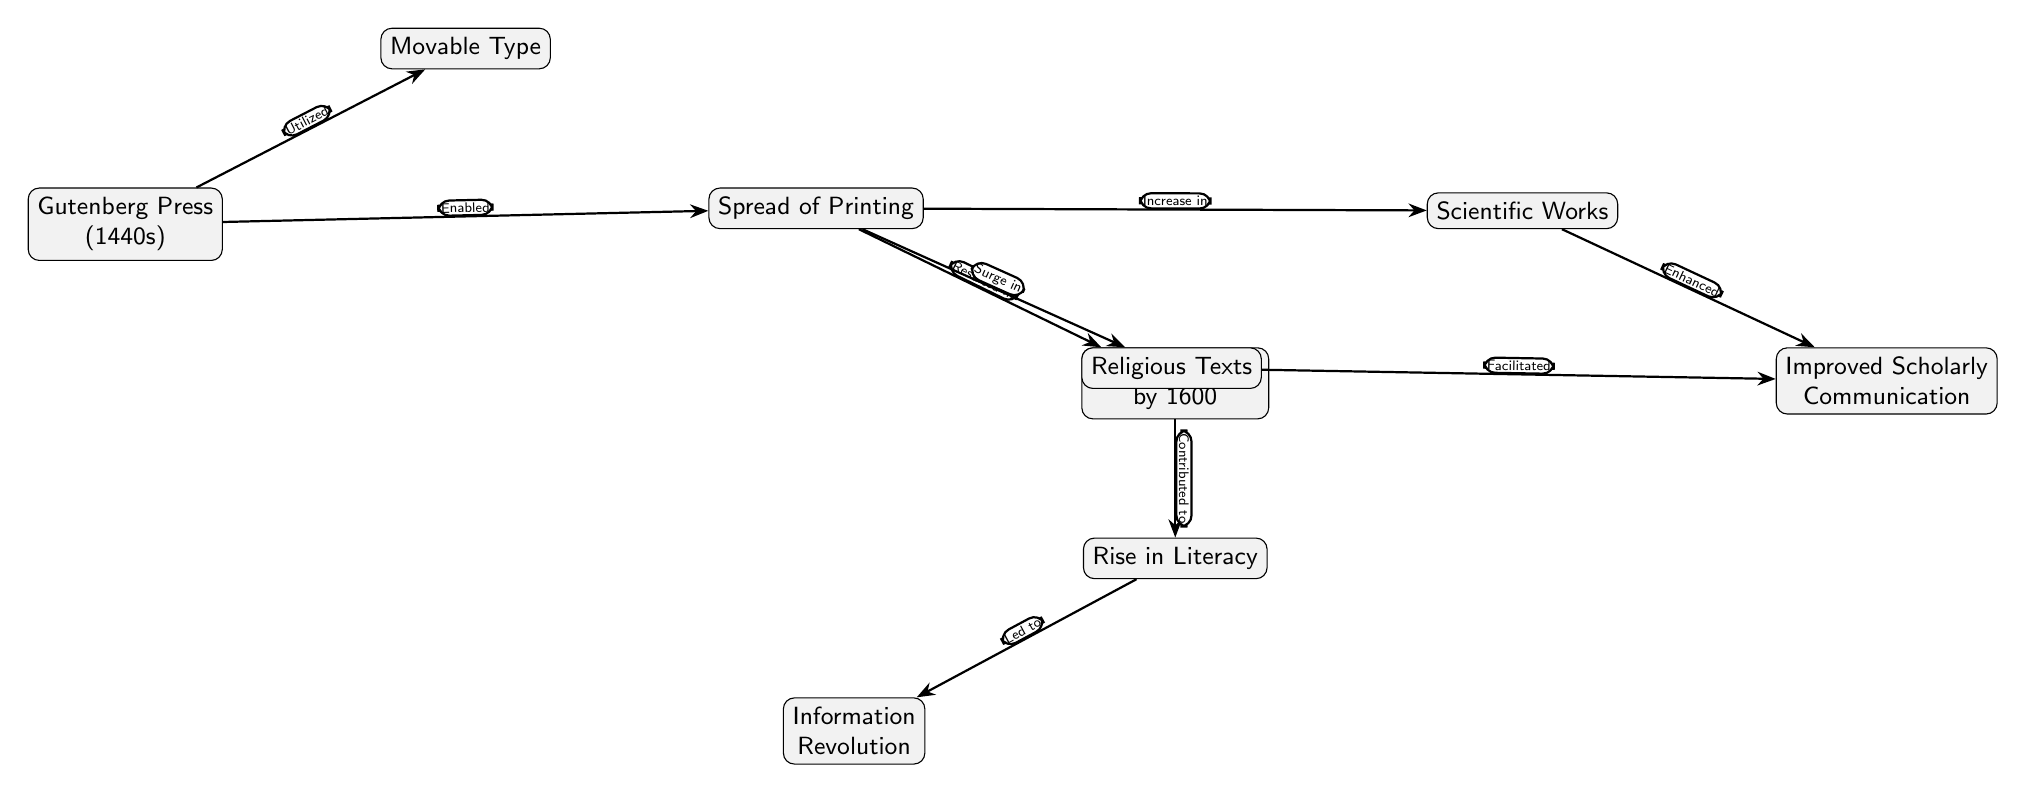What technology did Gutenberg utilize in the 1440s? The diagram indicates that Gutenberg utilized "Movable Type" as part of his printing technology in the 1440s. This is shown as a direct link from the "Gutenberg Press" node to the "Movable Type" node.
Answer: Movable Type How many books were available by the year 1600? According to the diagram, the "Books in 1600" node states there were "9 Million Books" by that time. This figure is explicitly stated within the node itself.
Answer: 9 Million Books What revolution is associated with the rise in literacy? The diagram links "Rise in Literacy" to "Information Revolution," indicating that the rise in literacy contributed to this broader revolution. Thus, the answer is found by following the line from the "Literacy Rise" node to "Information Revolution."
Answer: Information Revolution Which types of works experienced an increase due to the spread of printing? The diagram specifies that the "Spread of Printing" led to both "Scientific Works" and "Religious Texts." This is determined by examining the nodes directly connected to "Spread of Printing".
Answer: Scientific Works and Religious Texts What relationship does the Spread of Printing have with Scholarly Communication? According to the diagram, the "Spread of Printing" directly facilitates an "Increase in" both "Scientific Works" and "Surge in" "Religious Texts," which together enhance "Scholarly Communication." Therefore, the relationship shows that the spread contributes to improved communication among scholars.
Answer: Improved Scholarly Communication How did the Gutenberg Press impact knowledge dissemination? The diagram indicates that the Gutenberg Press "Enabled" the "Spread of Printing", which is the primary means by which knowledge was disseminated during this era. Hence, it directly links these two concepts, revealing the crucial role of the Gutenberg Press in information distribution.
Answer: Enabled the Spread of Printing What two major impacts resulted from the Spread of Printing? The diagram shows two significant impacts of the "Spread of Printing": the "Rise in Literacy" and the "Increase in Scientific Works." This can be derived by looking at the successive nodes that follow the "Spread of Printing".
Answer: Rise in Literacy and Increase in Scientific Works Which node is connected to both Religious Texts and Scientific Works? "Scholarly Communication" is a shared outcome linked to both "Religious Texts" and "Scientific Works". Understanding this involves tracing the connections leading from these two nodes to their common result, "Scholarly Communication."
Answer: Improved Scholarly Communication 